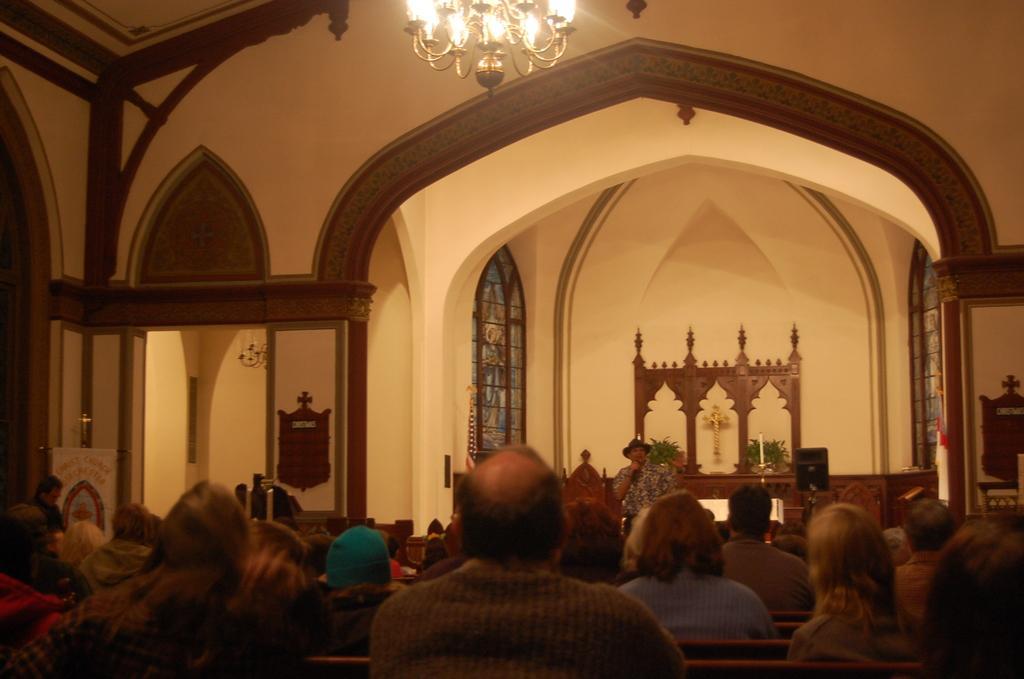Please provide a concise description of this image. In this image we can see a man standing and holding a mic. At the bottom there are people sitting and we can see walls, window and lights. At the top there is a chandelier. 